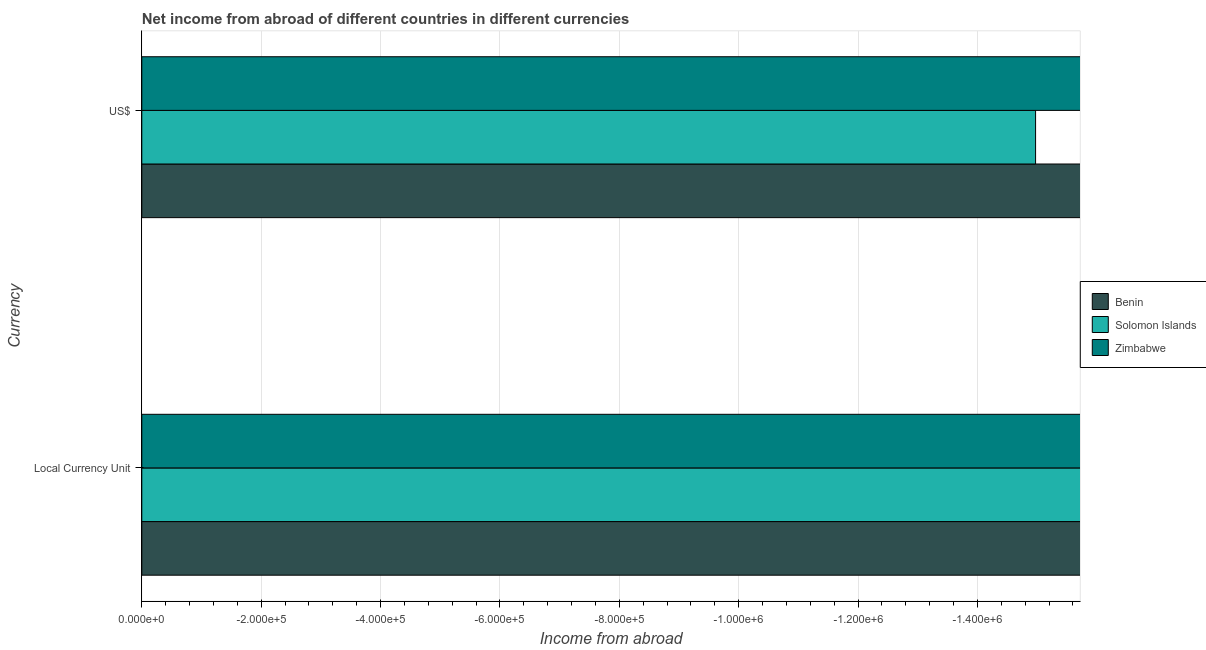Are the number of bars on each tick of the Y-axis equal?
Your answer should be very brief. Yes. How many bars are there on the 1st tick from the bottom?
Provide a succinct answer. 0. What is the label of the 2nd group of bars from the top?
Give a very brief answer. Local Currency Unit. What is the total income from abroad in constant 2005 us$ in the graph?
Ensure brevity in your answer.  0. What is the difference between the income from abroad in us$ in Solomon Islands and the income from abroad in constant 2005 us$ in Zimbabwe?
Give a very brief answer. 0. What is the average income from abroad in constant 2005 us$ per country?
Make the answer very short. 0. In how many countries, is the income from abroad in constant 2005 us$ greater than the average income from abroad in constant 2005 us$ taken over all countries?
Offer a very short reply. 0. How many countries are there in the graph?
Offer a very short reply. 3. Does the graph contain any zero values?
Ensure brevity in your answer.  Yes. Does the graph contain grids?
Offer a very short reply. Yes. Where does the legend appear in the graph?
Ensure brevity in your answer.  Center right. How are the legend labels stacked?
Give a very brief answer. Vertical. What is the title of the graph?
Your answer should be compact. Net income from abroad of different countries in different currencies. Does "Pacific island small states" appear as one of the legend labels in the graph?
Make the answer very short. No. What is the label or title of the X-axis?
Give a very brief answer. Income from abroad. What is the label or title of the Y-axis?
Provide a short and direct response. Currency. What is the Income from abroad in Benin in Local Currency Unit?
Give a very brief answer. 0. What is the Income from abroad of Benin in US$?
Give a very brief answer. 0. What is the Income from abroad in Zimbabwe in US$?
Provide a succinct answer. 0. What is the total Income from abroad of Solomon Islands in the graph?
Keep it short and to the point. 0. What is the average Income from abroad of Benin per Currency?
Make the answer very short. 0. 